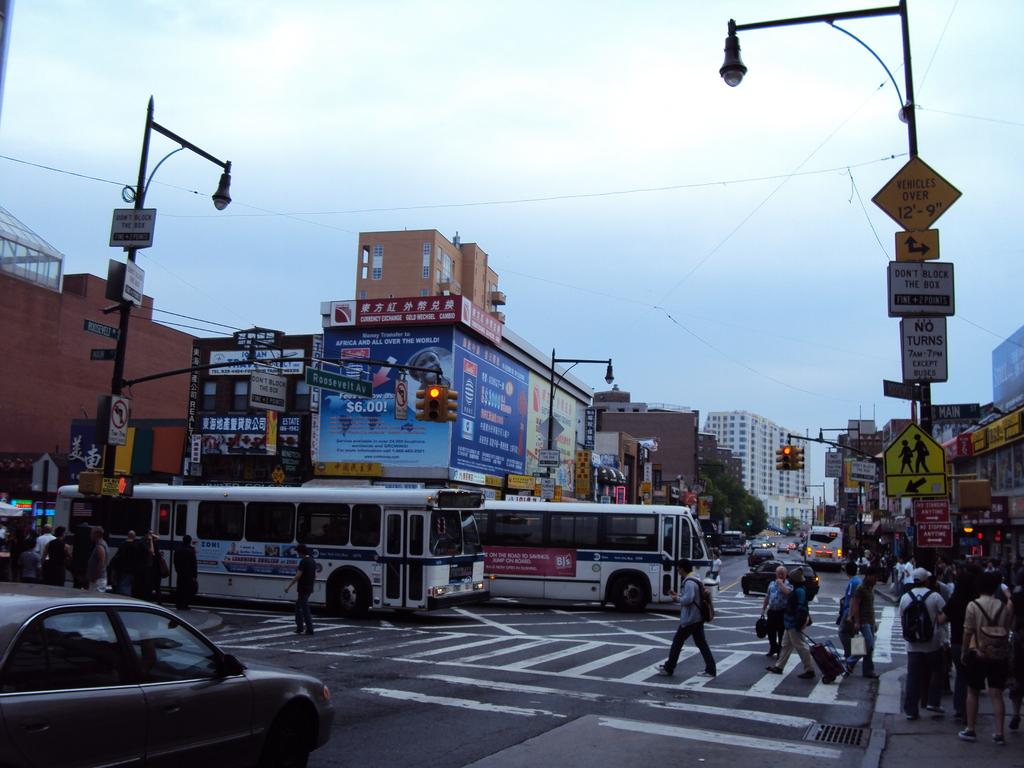Who or what can be seen in the image? There are people in the image. What can be seen controlling the flow of traffic in the image? There are traffic signals in the image. What objects are present in the image that might provide information or advertisements? There are boards and hoardings in the image. What type of structures can be seen in the background of the image? There are buildings in the background of the image. What natural elements can be seen in the background of the image? There are trees and the sky visible in the background of the image. What type of lighting is present in the image? There are lights on poles in the image. What type of fuel is being used by the people in the image? There is no information about fuel usage in the image; it focuses on people, traffic signals, boards, lights, buildings, hoardings, trees, and the sky. Are the people in the image wearing masks? There is no information about masks in the image; it focuses on people, traffic signals, boards, lights, buildings, hoardings, trees, and the sky. 